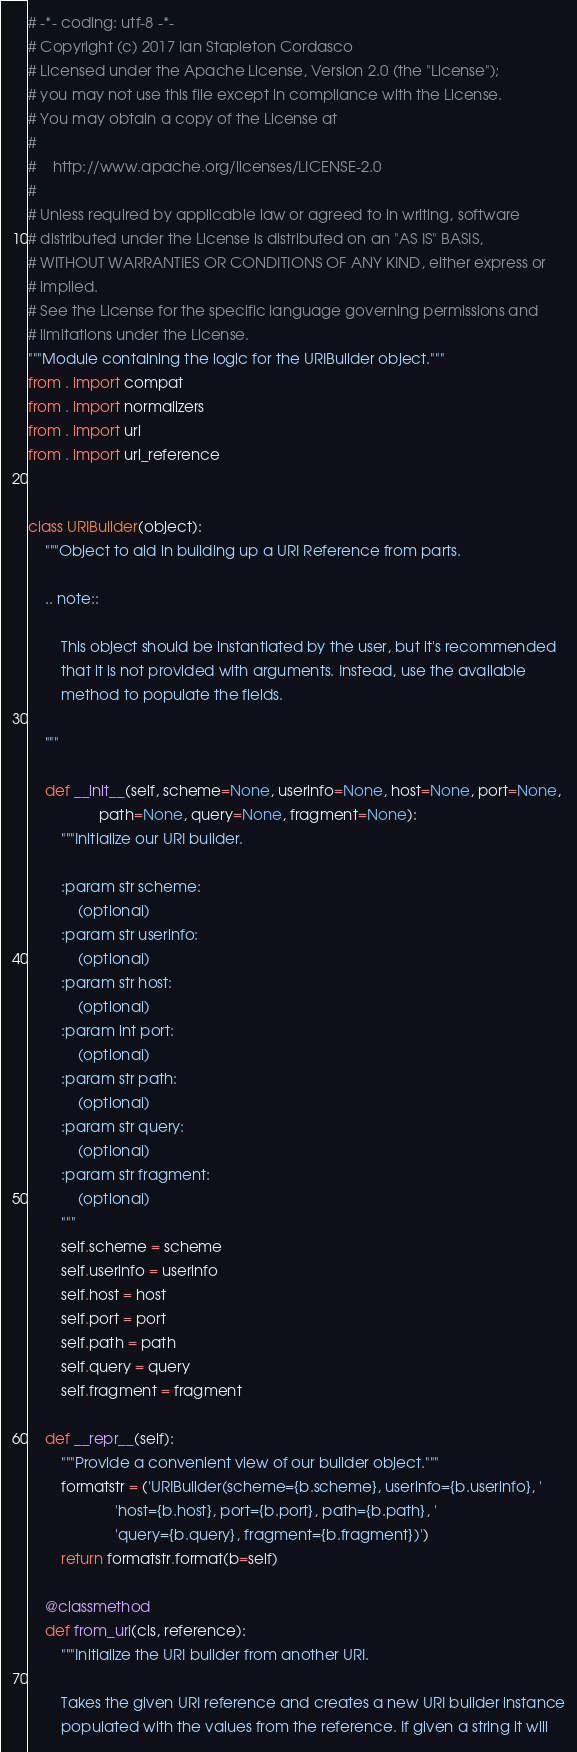<code> <loc_0><loc_0><loc_500><loc_500><_Python_># -*- coding: utf-8 -*-
# Copyright (c) 2017 Ian Stapleton Cordasco
# Licensed under the Apache License, Version 2.0 (the "License");
# you may not use this file except in compliance with the License.
# You may obtain a copy of the License at
#
#    http://www.apache.org/licenses/LICENSE-2.0
#
# Unless required by applicable law or agreed to in writing, software
# distributed under the License is distributed on an "AS IS" BASIS,
# WITHOUT WARRANTIES OR CONDITIONS OF ANY KIND, either express or
# implied.
# See the License for the specific language governing permissions and
# limitations under the License.
"""Module containing the logic for the URIBuilder object."""
from . import compat
from . import normalizers
from . import uri
from . import uri_reference


class URIBuilder(object):
    """Object to aid in building up a URI Reference from parts.

    .. note::

        This object should be instantiated by the user, but it's recommended
        that it is not provided with arguments. Instead, use the available
        method to populate the fields.

    """

    def __init__(self, scheme=None, userinfo=None, host=None, port=None,
                 path=None, query=None, fragment=None):
        """Initialize our URI builder.

        :param str scheme:
            (optional)
        :param str userinfo:
            (optional)
        :param str host:
            (optional)
        :param int port:
            (optional)
        :param str path:
            (optional)
        :param str query:
            (optional)
        :param str fragment:
            (optional)
        """
        self.scheme = scheme
        self.userinfo = userinfo
        self.host = host
        self.port = port
        self.path = path
        self.query = query
        self.fragment = fragment

    def __repr__(self):
        """Provide a convenient view of our builder object."""
        formatstr = ('URIBuilder(scheme={b.scheme}, userinfo={b.userinfo}, '
                     'host={b.host}, port={b.port}, path={b.path}, '
                     'query={b.query}, fragment={b.fragment})')
        return formatstr.format(b=self)

    @classmethod
    def from_uri(cls, reference):
        """Initialize the URI builder from another URI.

        Takes the given URI reference and creates a new URI builder instance
        populated with the values from the reference. If given a string it will</code> 